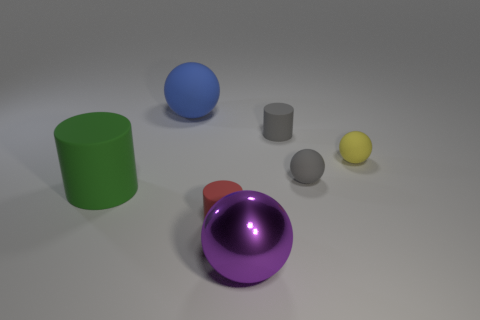What colors are present in the objects in the image? The objects in the image consist of a variety of colors including red, green, blue, purple, gray, and yellow. 